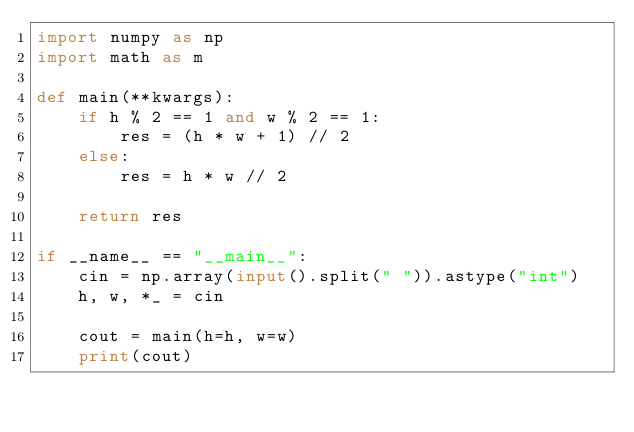Convert code to text. <code><loc_0><loc_0><loc_500><loc_500><_Python_>import numpy as np
import math as m

def main(**kwargs):
    if h % 2 == 1 and w % 2 == 1:
        res = (h * w + 1) // 2
    else:
        res = h * w // 2

    return res

if __name__ == "__main__":
    cin = np.array(input().split(" ")).astype("int")
    h, w, *_ = cin

    cout = main(h=h, w=w)
    print(cout)</code> 